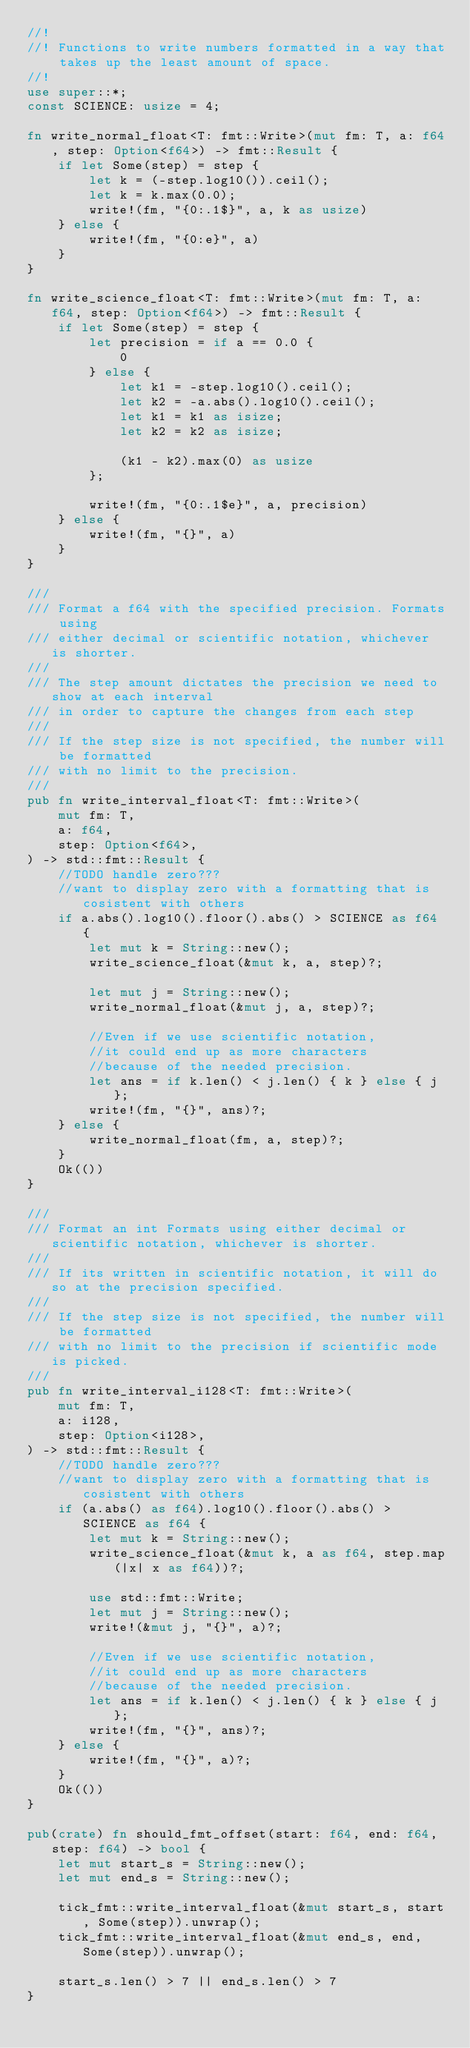Convert code to text. <code><loc_0><loc_0><loc_500><loc_500><_Rust_>//!
//! Functions to write numbers formatted in a way that takes up the least amount of space.
//!
use super::*;
const SCIENCE: usize = 4;

fn write_normal_float<T: fmt::Write>(mut fm: T, a: f64, step: Option<f64>) -> fmt::Result {
    if let Some(step) = step {
        let k = (-step.log10()).ceil();
        let k = k.max(0.0);
        write!(fm, "{0:.1$}", a, k as usize)
    } else {
        write!(fm, "{0:e}", a)
    }
}

fn write_science_float<T: fmt::Write>(mut fm: T, a: f64, step: Option<f64>) -> fmt::Result {
    if let Some(step) = step {
        let precision = if a == 0.0 {
            0
        } else {
            let k1 = -step.log10().ceil();
            let k2 = -a.abs().log10().ceil();
            let k1 = k1 as isize;
            let k2 = k2 as isize;

            (k1 - k2).max(0) as usize
        };

        write!(fm, "{0:.1$e}", a, precision)
    } else {
        write!(fm, "{}", a)
    }
}

///
/// Format a f64 with the specified precision. Formats using
/// either decimal or scientific notation, whichever is shorter.
///
/// The step amount dictates the precision we need to show at each interval
/// in order to capture the changes from each step
///
/// If the step size is not specified, the number will be formatted
/// with no limit to the precision.
///
pub fn write_interval_float<T: fmt::Write>(
    mut fm: T,
    a: f64,
    step: Option<f64>,
) -> std::fmt::Result {
    //TODO handle zero???
    //want to display zero with a formatting that is cosistent with others
    if a.abs().log10().floor().abs() > SCIENCE as f64 {
        let mut k = String::new();
        write_science_float(&mut k, a, step)?;

        let mut j = String::new();
        write_normal_float(&mut j, a, step)?;

        //Even if we use scientific notation,
        //it could end up as more characters
        //because of the needed precision.
        let ans = if k.len() < j.len() { k } else { j };
        write!(fm, "{}", ans)?;
    } else {
        write_normal_float(fm, a, step)?;
    }
    Ok(())
}

///
/// Format an int Formats using either decimal or scientific notation, whichever is shorter.
///
/// If its written in scientific notation, it will do so at the precision specified.
///
/// If the step size is not specified, the number will be formatted
/// with no limit to the precision if scientific mode is picked.
///
pub fn write_interval_i128<T: fmt::Write>(
    mut fm: T,
    a: i128,
    step: Option<i128>,
) -> std::fmt::Result {
    //TODO handle zero???
    //want to display zero with a formatting that is cosistent with others
    if (a.abs() as f64).log10().floor().abs() > SCIENCE as f64 {
        let mut k = String::new();
        write_science_float(&mut k, a as f64, step.map(|x| x as f64))?;

        use std::fmt::Write;
        let mut j = String::new();
        write!(&mut j, "{}", a)?;

        //Even if we use scientific notation,
        //it could end up as more characters
        //because of the needed precision.
        let ans = if k.len() < j.len() { k } else { j };
        write!(fm, "{}", ans)?;
    } else {
        write!(fm, "{}", a)?;
    }
    Ok(())
}

pub(crate) fn should_fmt_offset(start: f64, end: f64, step: f64) -> bool {
    let mut start_s = String::new();
    let mut end_s = String::new();

    tick_fmt::write_interval_float(&mut start_s, start, Some(step)).unwrap();
    tick_fmt::write_interval_float(&mut end_s, end, Some(step)).unwrap();

    start_s.len() > 7 || end_s.len() > 7
}
</code> 